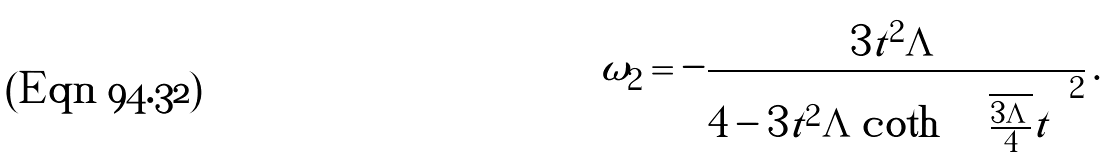Convert formula to latex. <formula><loc_0><loc_0><loc_500><loc_500>\omega _ { 2 } = - \frac { 3 t ^ { 2 } \Lambda } { 4 - 3 t ^ { 2 } \Lambda \coth \left [ \sqrt { \frac { 3 \Lambda } { 4 } } t \right ] ^ { 2 } } \, .</formula> 